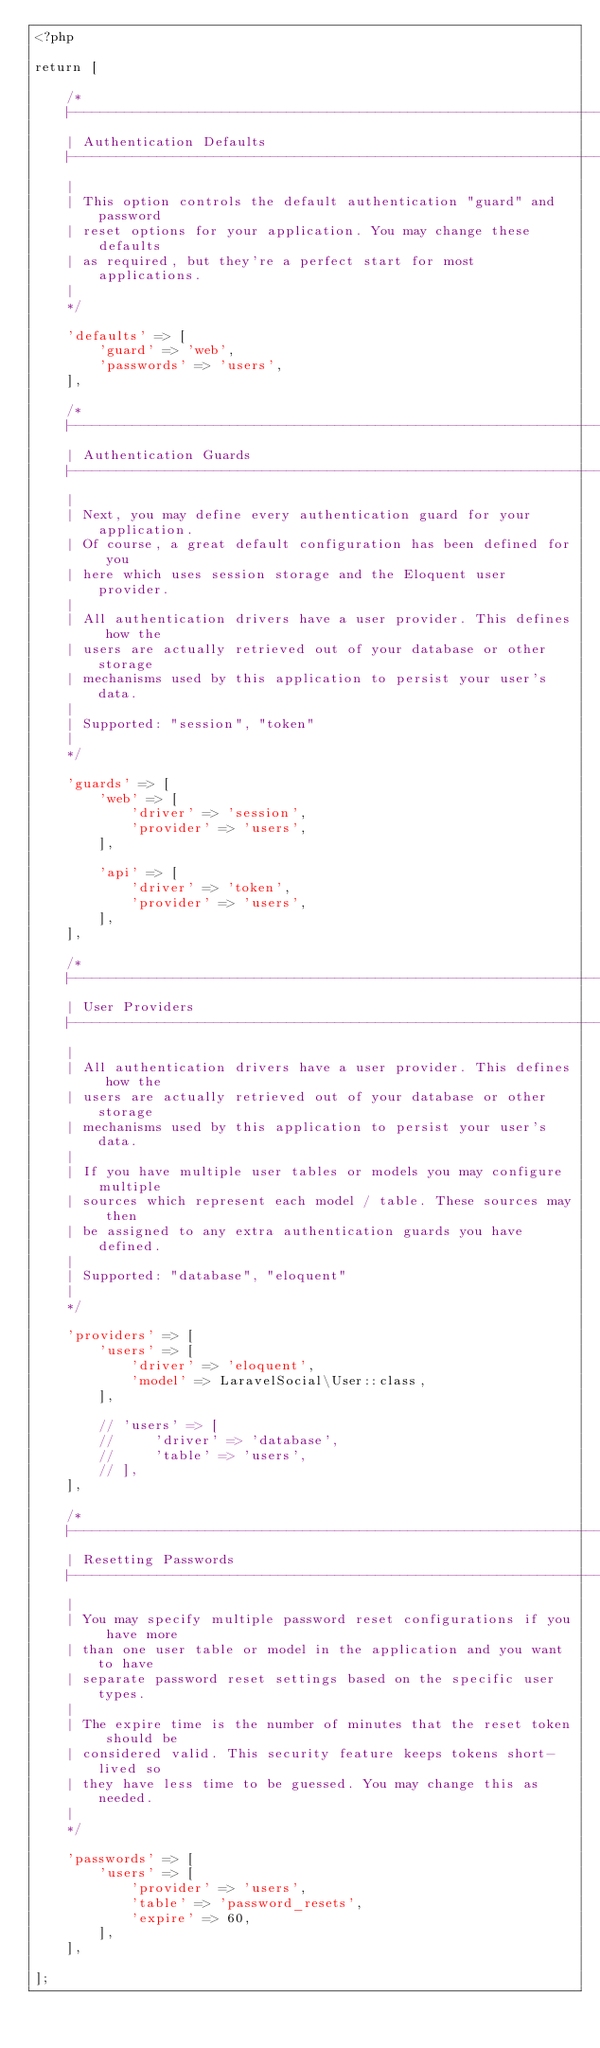Convert code to text. <code><loc_0><loc_0><loc_500><loc_500><_PHP_><?php

return [

    /*
    |--------------------------------------------------------------------------
    | Authentication Defaults
    |--------------------------------------------------------------------------
    |
    | This option controls the default authentication "guard" and password
    | reset options for your application. You may change these defaults
    | as required, but they're a perfect start for most applications.
    |
    */

    'defaults' => [
        'guard' => 'web',
        'passwords' => 'users',
    ],

    /*
    |--------------------------------------------------------------------------
    | Authentication Guards
    |--------------------------------------------------------------------------
    |
    | Next, you may define every authentication guard for your application.
    | Of course, a great default configuration has been defined for you
    | here which uses session storage and the Eloquent user provider.
    |
    | All authentication drivers have a user provider. This defines how the
    | users are actually retrieved out of your database or other storage
    | mechanisms used by this application to persist your user's data.
    |
    | Supported: "session", "token"
    |
    */

    'guards' => [
        'web' => [
            'driver' => 'session',
            'provider' => 'users',
        ],

        'api' => [
            'driver' => 'token',
            'provider' => 'users',
        ],
    ],

    /*
    |--------------------------------------------------------------------------
    | User Providers
    |--------------------------------------------------------------------------
    |
    | All authentication drivers have a user provider. This defines how the
    | users are actually retrieved out of your database or other storage
    | mechanisms used by this application to persist your user's data.
    |
    | If you have multiple user tables or models you may configure multiple
    | sources which represent each model / table. These sources may then
    | be assigned to any extra authentication guards you have defined.
    |
    | Supported: "database", "eloquent"
    |
    */

    'providers' => [
        'users' => [
            'driver' => 'eloquent',
            'model' => LaravelSocial\User::class,
        ],

        // 'users' => [
        //     'driver' => 'database',
        //     'table' => 'users',
        // ],
    ],

    /*
    |--------------------------------------------------------------------------
    | Resetting Passwords
    |--------------------------------------------------------------------------
    |
    | You may specify multiple password reset configurations if you have more
    | than one user table or model in the application and you want to have
    | separate password reset settings based on the specific user types.
    |
    | The expire time is the number of minutes that the reset token should be
    | considered valid. This security feature keeps tokens short-lived so
    | they have less time to be guessed. You may change this as needed.
    |
    */

    'passwords' => [
        'users' => [
            'provider' => 'users',
            'table' => 'password_resets',
            'expire' => 60,
        ],
    ],

];
</code> 